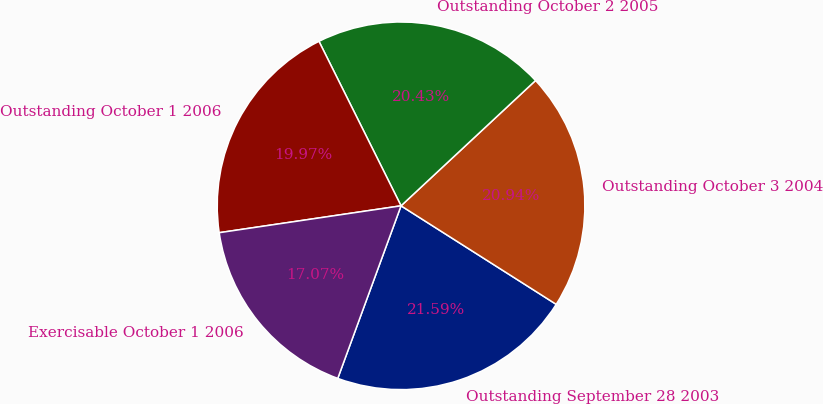Convert chart to OTSL. <chart><loc_0><loc_0><loc_500><loc_500><pie_chart><fcel>Outstanding September 28 2003<fcel>Outstanding October 3 2004<fcel>Outstanding October 2 2005<fcel>Outstanding October 1 2006<fcel>Exercisable October 1 2006<nl><fcel>21.59%<fcel>20.94%<fcel>20.43%<fcel>19.97%<fcel>17.07%<nl></chart> 